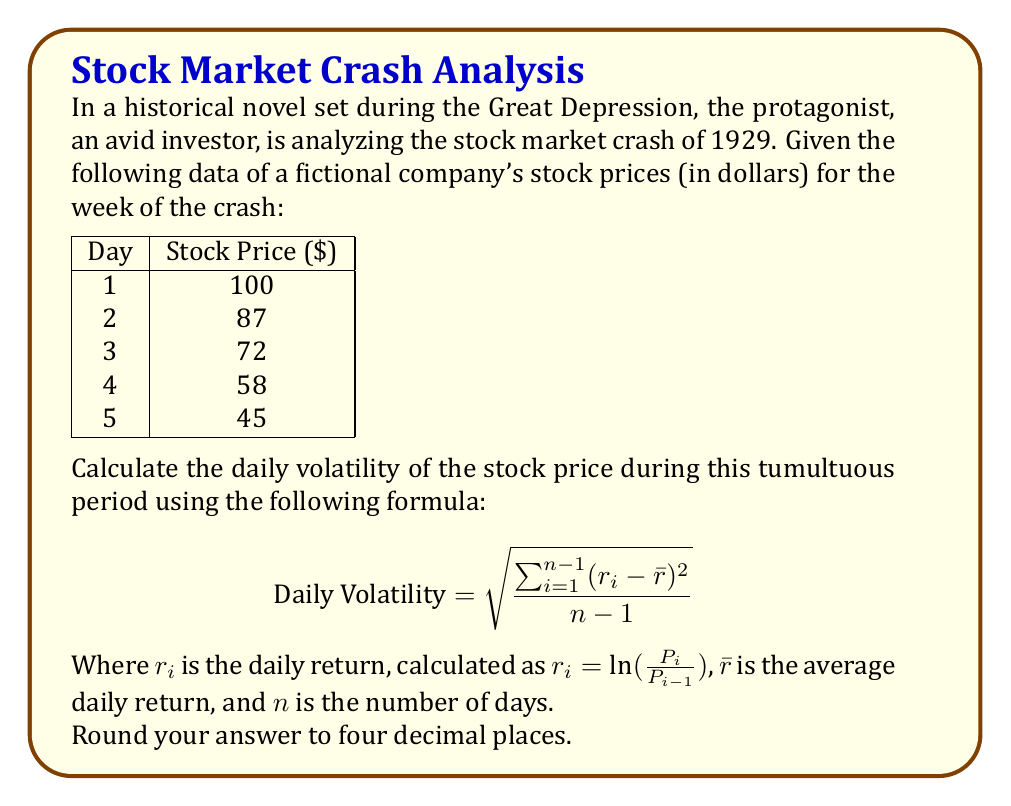Teach me how to tackle this problem. Let's approach this step-by-step:

1) First, calculate the daily returns:

   $r_1 = \ln(\frac{87}{100}) = -0.1393$
   $r_2 = \ln(\frac{72}{87}) = -0.1890$
   $r_3 = \ln(\frac{58}{72}) = -0.2163$
   $r_4 = \ln(\frac{45}{58}) = -0.2536$

2) Calculate the average daily return:

   $\bar{r} = \frac{-0.1393 + (-0.1890) + (-0.2163) + (-0.2536)}{4} = -0.1996$

3) Calculate $(r_i - \bar{r})^2$ for each day:

   $(r_1 - \bar{r})^2 = (-0.1393 - (-0.1996))^2 = 0.003636$
   $(r_2 - \bar{r})^2 = (-0.1890 - (-0.1996))^2 = 0.000112$
   $(r_3 - \bar{r})^2 = (-0.2163 - (-0.1996))^2 = 0.000279$
   $(r_4 - \bar{r})^2 = (-0.2536 - (-0.1996))^2 = 0.002916$

4) Sum these values:

   $\sum_{i=1}^{n-1} (r_i - \bar{r})^2 = 0.003636 + 0.000112 + 0.000279 + 0.002916 = 0.006943$

5) Divide by $(n-1) = 3$ and take the square root:

   $\text{Daily Volatility} = \sqrt{\frac{0.006943}{3}} = 0.0481$

6) Rounding to four decimal places:

   $\text{Daily Volatility} = 0.0481$
Answer: 0.0481 